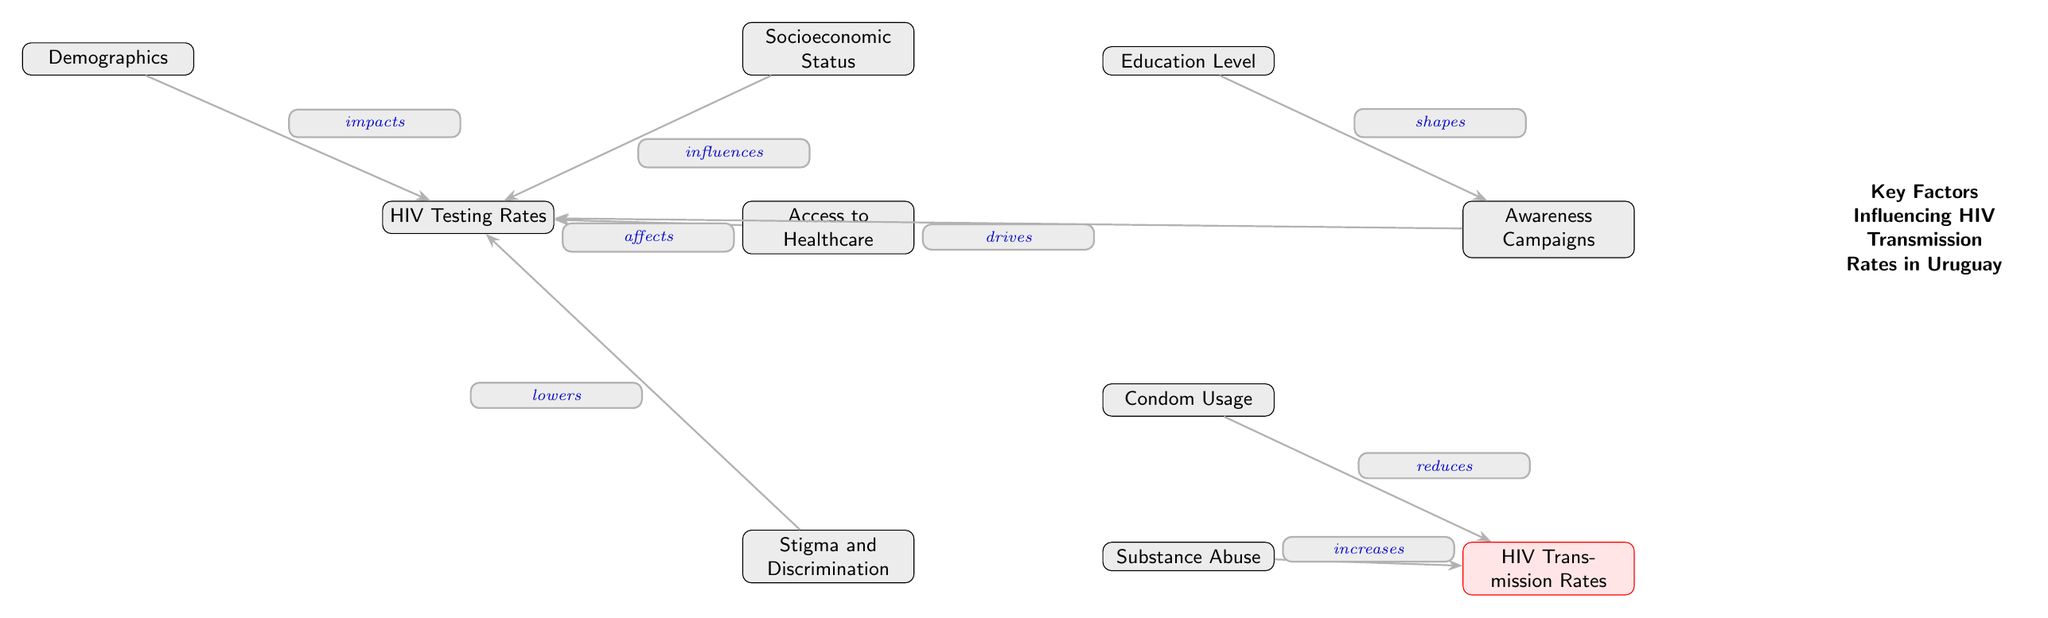What is the first node in the diagram? The first node in the diagram is "Demographics," which sits at the top left position.
Answer: Demographics How many nodes are there in total? By counting each unique node represented in the diagram, there are a total of 10 nodes.
Answer: 10 What is the relationship between "Socioeconomic Status" and "HIV Testing Rates"? "Socioeconomic Status" influences "HIV Testing Rates," as indicated by the directed edge labeled "influences" connecting the two nodes.
Answer: influences Which node is affected by both "Access to Healthcare" and "HIV Testing Rates"? Both "Access to Healthcare" and "HIV Testing Rates" impact "HIV Testing Rates," as seen from the edges leading directly to the "HIV Testing Rates" node.
Answer: HIV Testing Rates What does the node "Condom Usage" do to the "HIV Transmission Rates"? "Condom Usage" reduces "HIV Transmission Rates," as shown by the edge labeled "reduces" pointing towards the "HIV Transmission Rates" node.
Answer: reduces How does "Stigma and Discrimination" influence "HIV Testing Rates"? "Stigma and Discrimination" lowers "HIV Testing Rates," which is indicated by the directed edge that connects "Stigma and Discrimination" to "HIV Testing Rates."
Answer: lowers What is the effect of "Substance Abuse" on "HIV Transmission Rates"? "Substance Abuse" increases "HIV Transmission Rates," according to the edge labeled "increases" directing towards the "HIV Transmission Rates" node.
Answer: increases Which nodes indirectly influence "HIV Testing Rates"? The nodes "Demographics," "Socioeconomic Status," "Access to Healthcare," and "Stigma and Discrimination" all provide indirect influences on "HIV Testing Rates."
Answer: Demographics, Socioeconomic Status, Access to Healthcare, Stigma and Discrimination What role do "Education Level" and "Awareness Campaigns" play in the diagram? "Education Level" shapes "Awareness Campaigns," and "Awareness Campaigns" drives "HIV Testing Rates," demonstrating a causal and sequential relationship between these nodes.
Answer: shapes, drives 